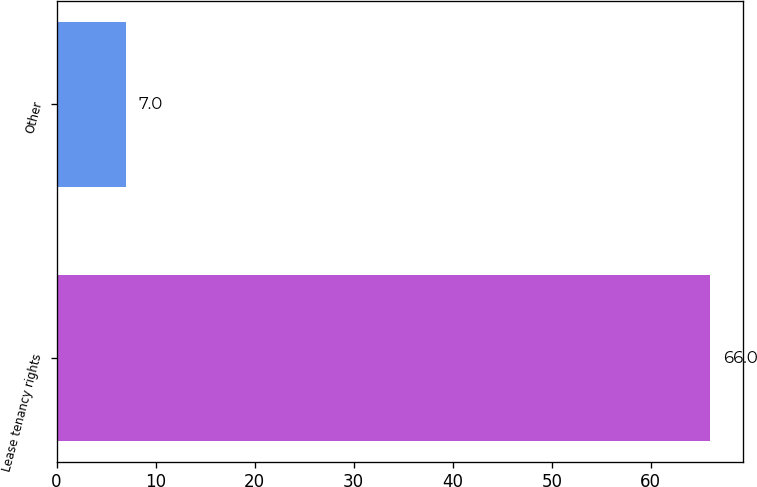Convert chart. <chart><loc_0><loc_0><loc_500><loc_500><bar_chart><fcel>Lease tenancy rights<fcel>Other<nl><fcel>66<fcel>7<nl></chart> 